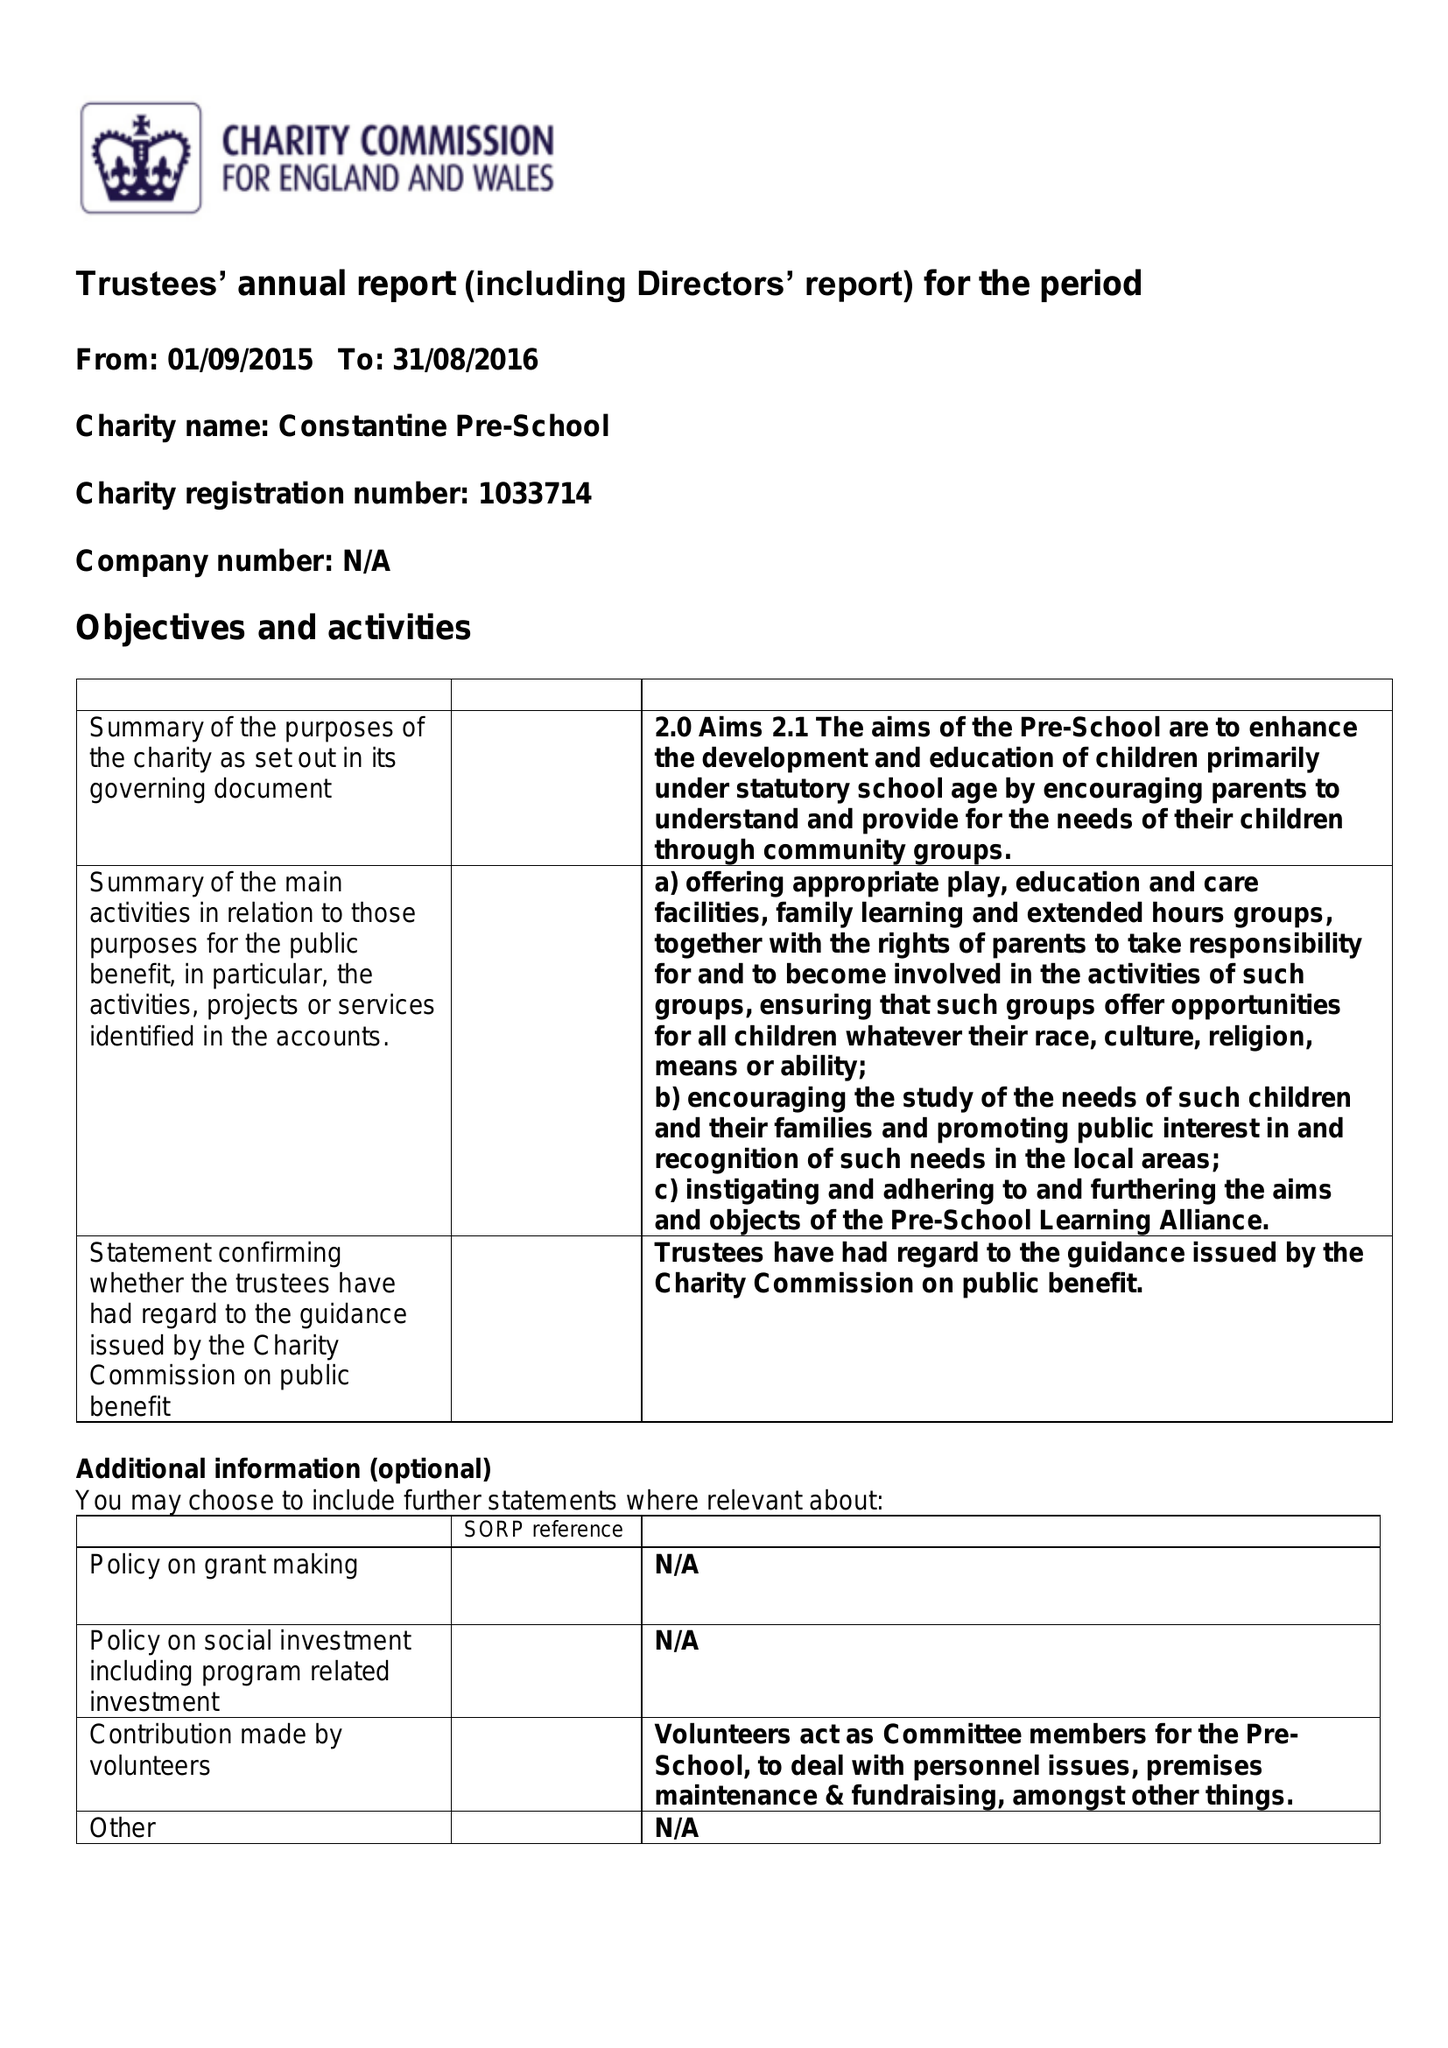What is the value for the income_annually_in_british_pounds?
Answer the question using a single word or phrase. 76352.00 